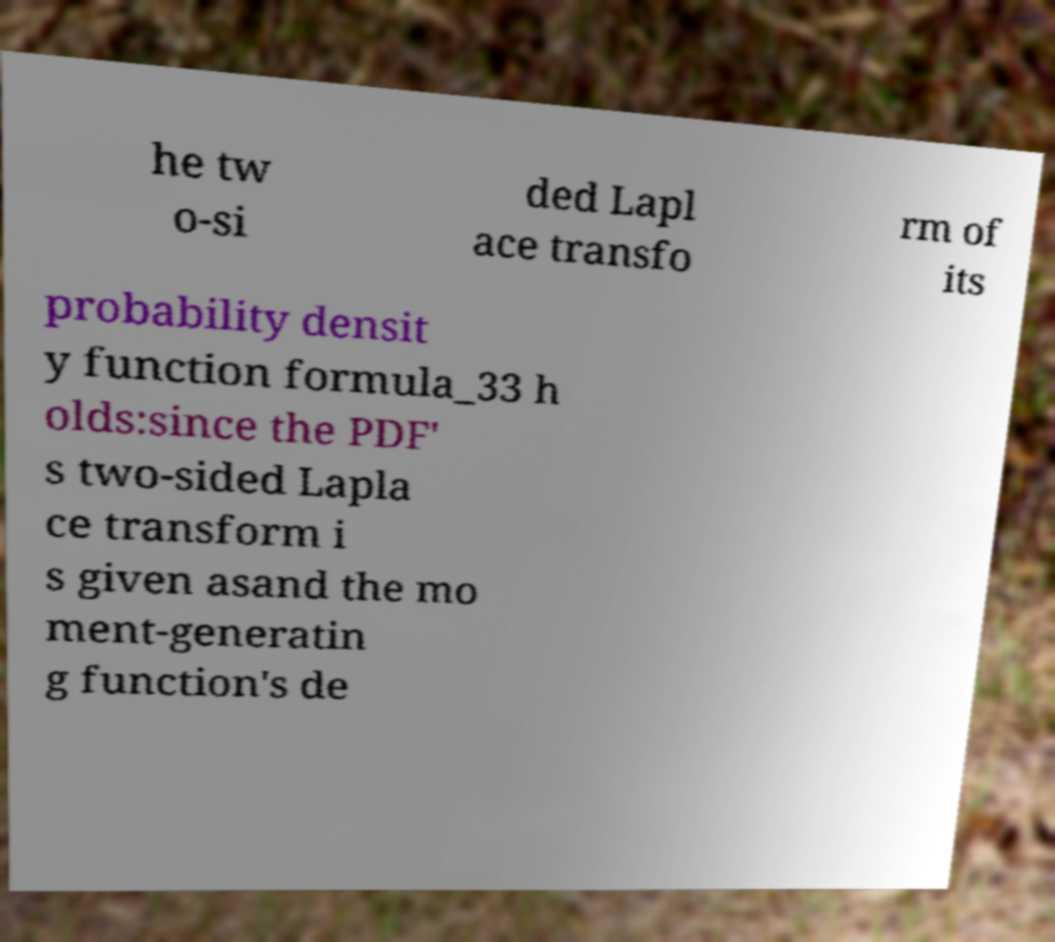Please identify and transcribe the text found in this image. he tw o-si ded Lapl ace transfo rm of its probability densit y function formula_33 h olds:since the PDF' s two-sided Lapla ce transform i s given asand the mo ment-generatin g function's de 